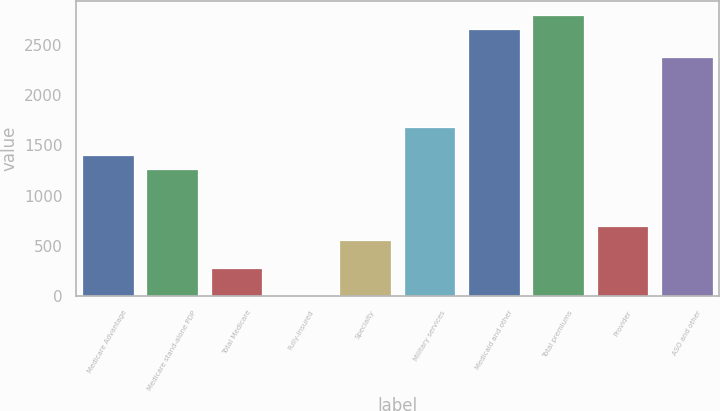<chart> <loc_0><loc_0><loc_500><loc_500><bar_chart><fcel>Medicare Advantage<fcel>Medicare stand-alone PDP<fcel>Total Medicare<fcel>Fully-insured<fcel>Specialty<fcel>Military services<fcel>Medicaid and other<fcel>Total premiums<fcel>Provider<fcel>ASO and other<nl><fcel>1401.01<fcel>1260.98<fcel>280.81<fcel>0.75<fcel>560.87<fcel>1681.07<fcel>2661.22<fcel>2801.24<fcel>700.89<fcel>2381.18<nl></chart> 